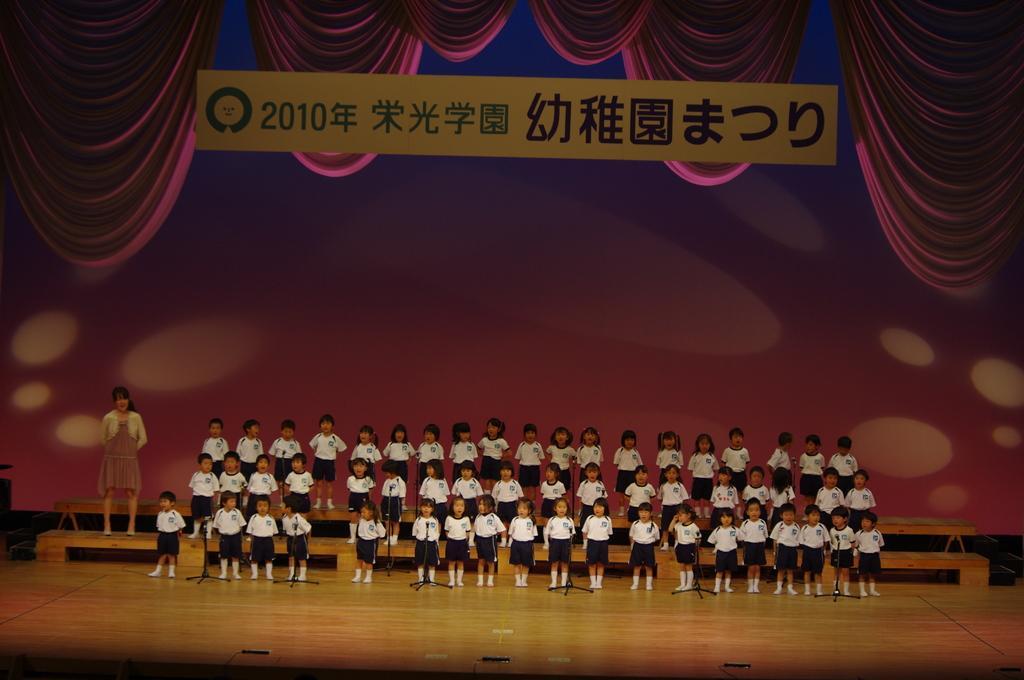Can you describe this image briefly? In the image there are a group of kids standing on the stage and on the left side there is a woman, behind the kids there is some text and around that text there are animated curtains. 